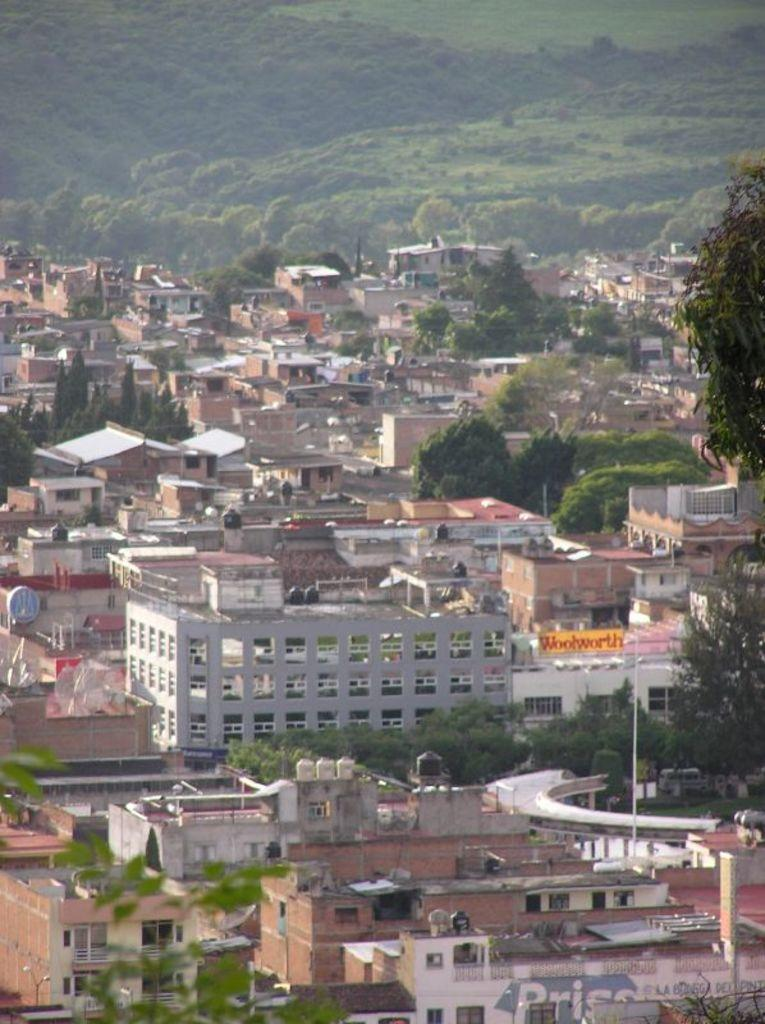What type of structures can be seen in the image? There are buildings in the image. What natural elements are present in the image? There are trees in the image. What man-made objects can be seen in the image? There are poles in the image. What can be seen in the background of the image? There are trees, the ground, and grass in the background of the image. How many branches are visible on the trees in the image? There is no specific mention of branches on the trees in the image, so it is not possible to determine the number of branches. Can you see any snakes slithering through the grass in the image? There is no mention of snakes in the image, so it is not possible to determine if any are present. 